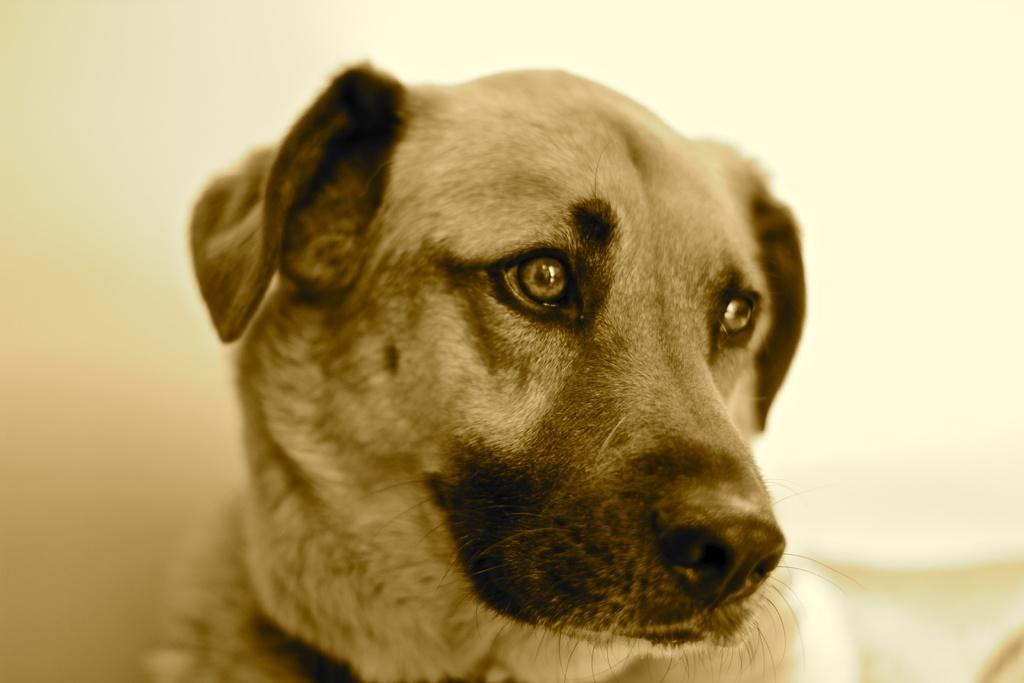What type of animal is in the image? There is a dog in the image. What can be seen in the background of the image? There is a wall in the background of the image. Can you describe the object on the right side of the image? Unfortunately, the facts provided do not give any information about the object on the right side of the image. What color is the sky in the image? The facts provided do not mention the sky, so we cannot determine its color from the image. How many matches are visible in the image? There are no matches present in the image. 